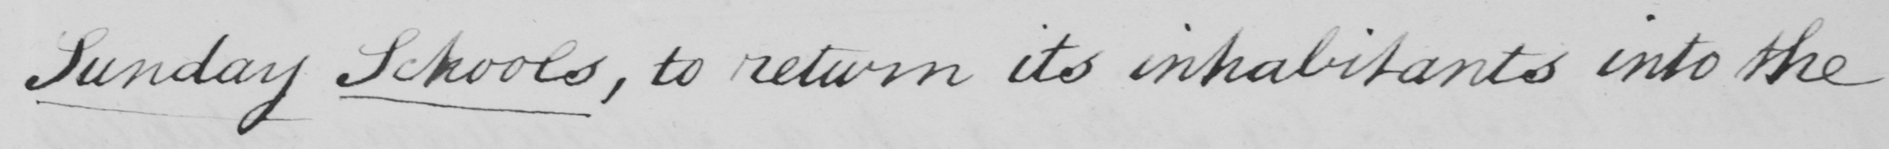What is written in this line of handwriting? Sunday Schools , to return its inhabitants into the 